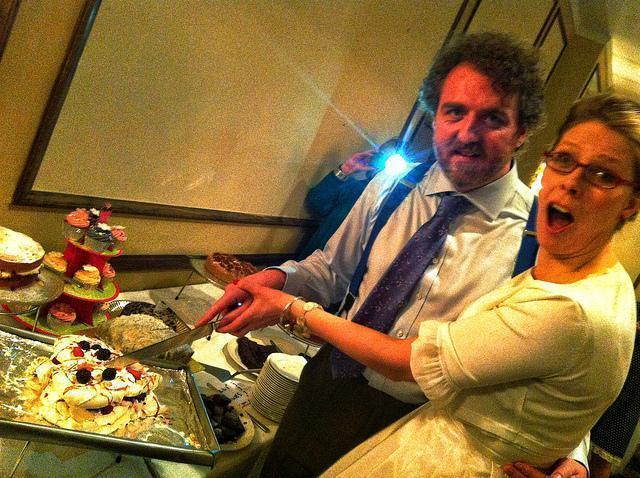Why is the man behind the other two holding a flashing object?
Pick the right solution, then justify: 'Answer: answer
Rationale: rationale.'
Options: Being annoying, making art, being funny, taking pictures. Answer: taking pictures.
Rationale: The person appears to be holding a camera and the flash would go off at the moment a picture was taken. the couple also appear to be posing which would also be consistent with answer a. 